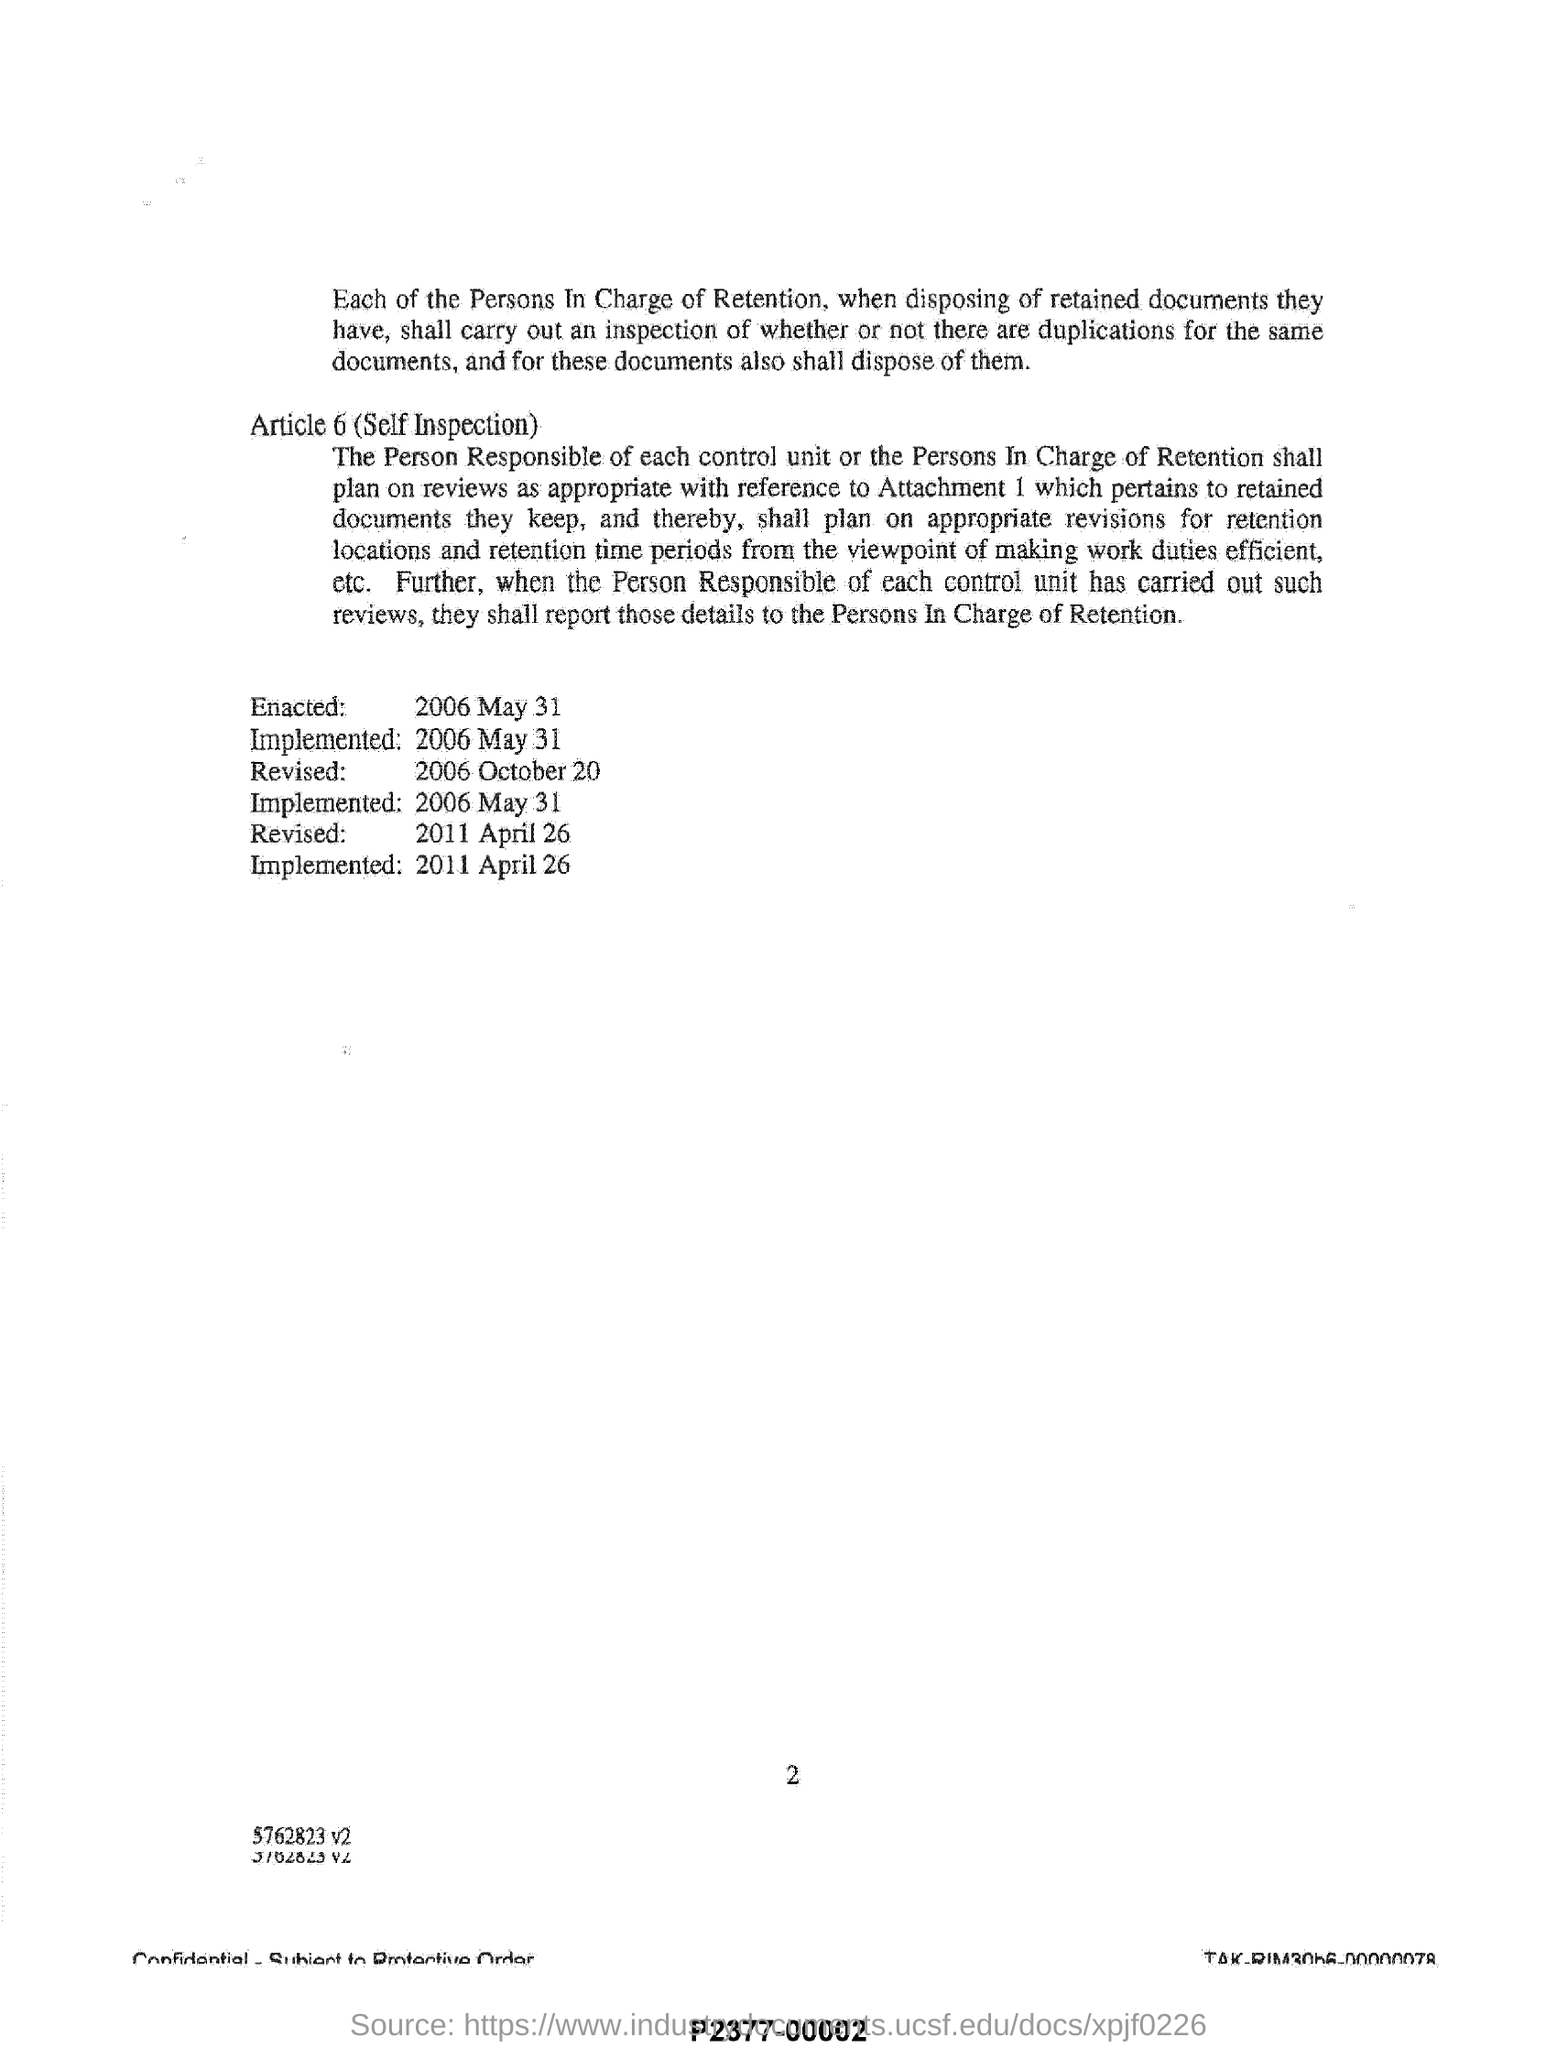What is the name of the Article 6?
Your answer should be very brief. Self Inspection. When was this document Enacted?
Keep it short and to the point. 2006 May 31. When was the second revision?
Your response must be concise. 2011 April 26. When was this document Revised first?
Make the answer very short. 2006 October 20. 